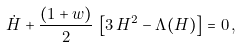Convert formula to latex. <formula><loc_0><loc_0><loc_500><loc_500>\dot { H } + \frac { ( 1 + w ) } { 2 } \, \left [ 3 \, H ^ { 2 } - \Lambda ( H ) \right ] = 0 \, ,</formula> 